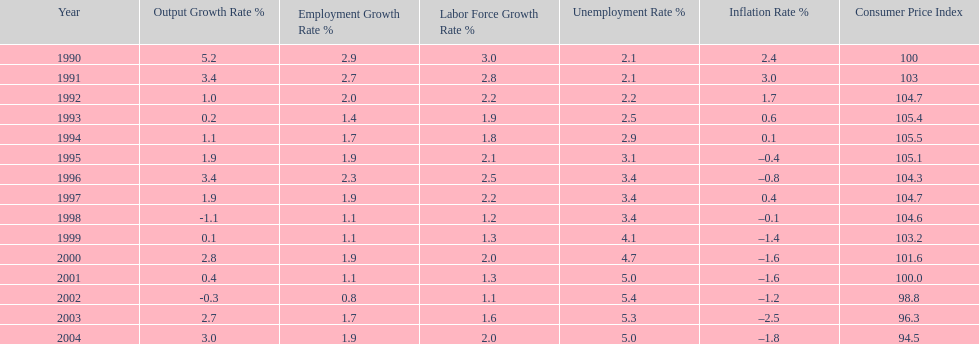In what years, between 1990 and 2004, did japan's unemployment rate reach 5% or higher? 4. 